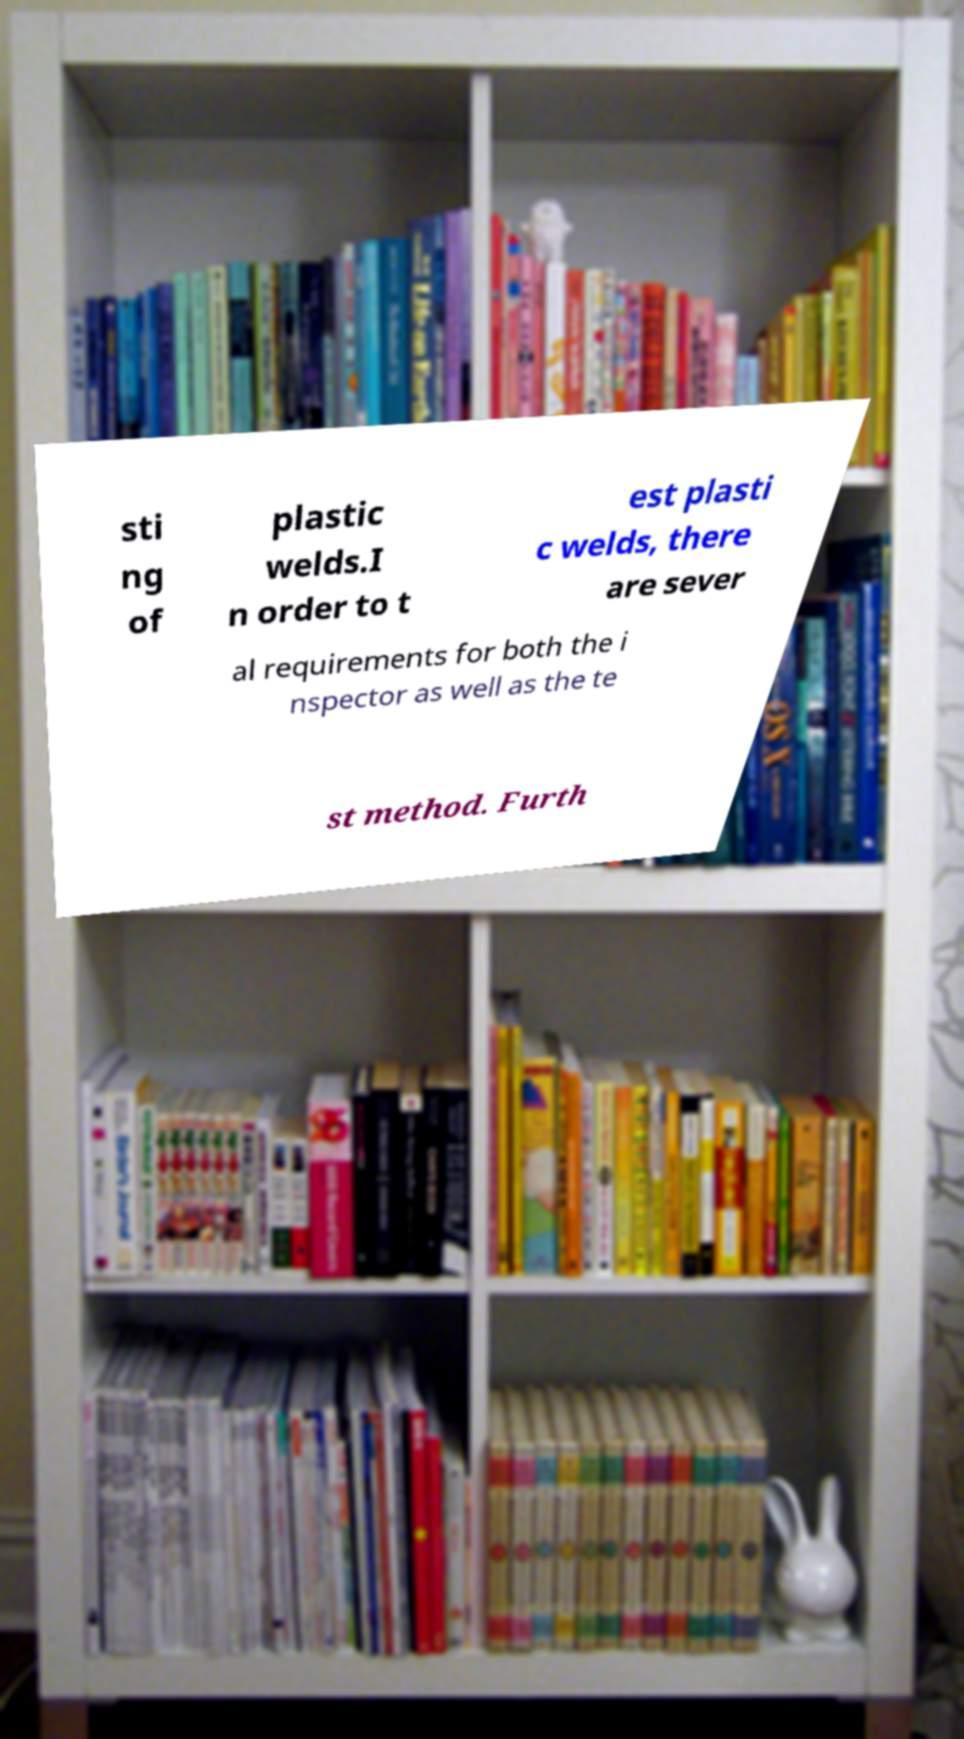There's text embedded in this image that I need extracted. Can you transcribe it verbatim? sti ng of plastic welds.I n order to t est plasti c welds, there are sever al requirements for both the i nspector as well as the te st method. Furth 